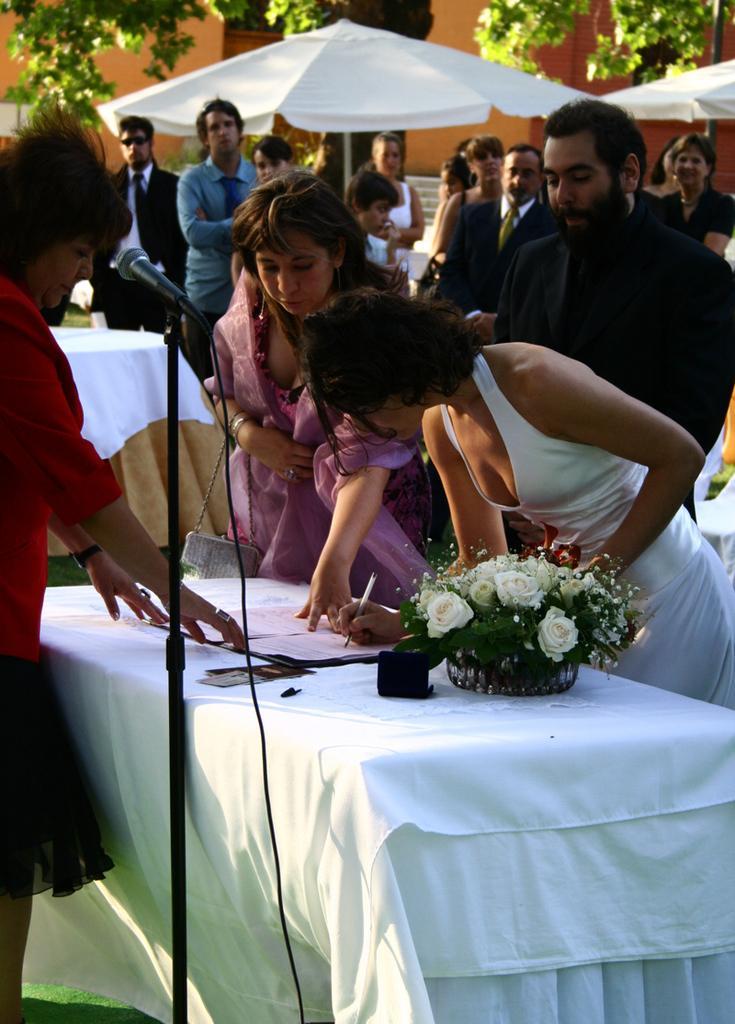Can you describe this image briefly? In this picture we can see a people standing near to the table and one woman is standing and signing something on the paper on the table, on the table we can also find flower vase with flowers and with white cloth, in the background we can see some people are standing and watching them and there is also a umbrella, tree leaves, and building wall. 